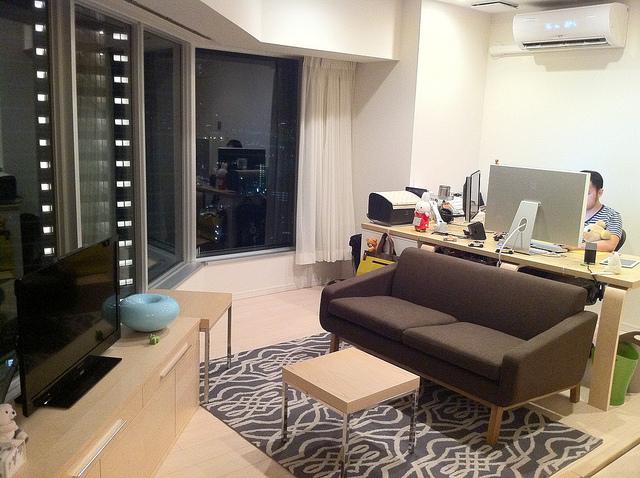Is the person working or playing on the computer?
Answer briefly. Working. Does the person at the desk work at home?
Give a very brief answer. Yes. Is there a rug in the room?
Write a very short answer. Yes. 